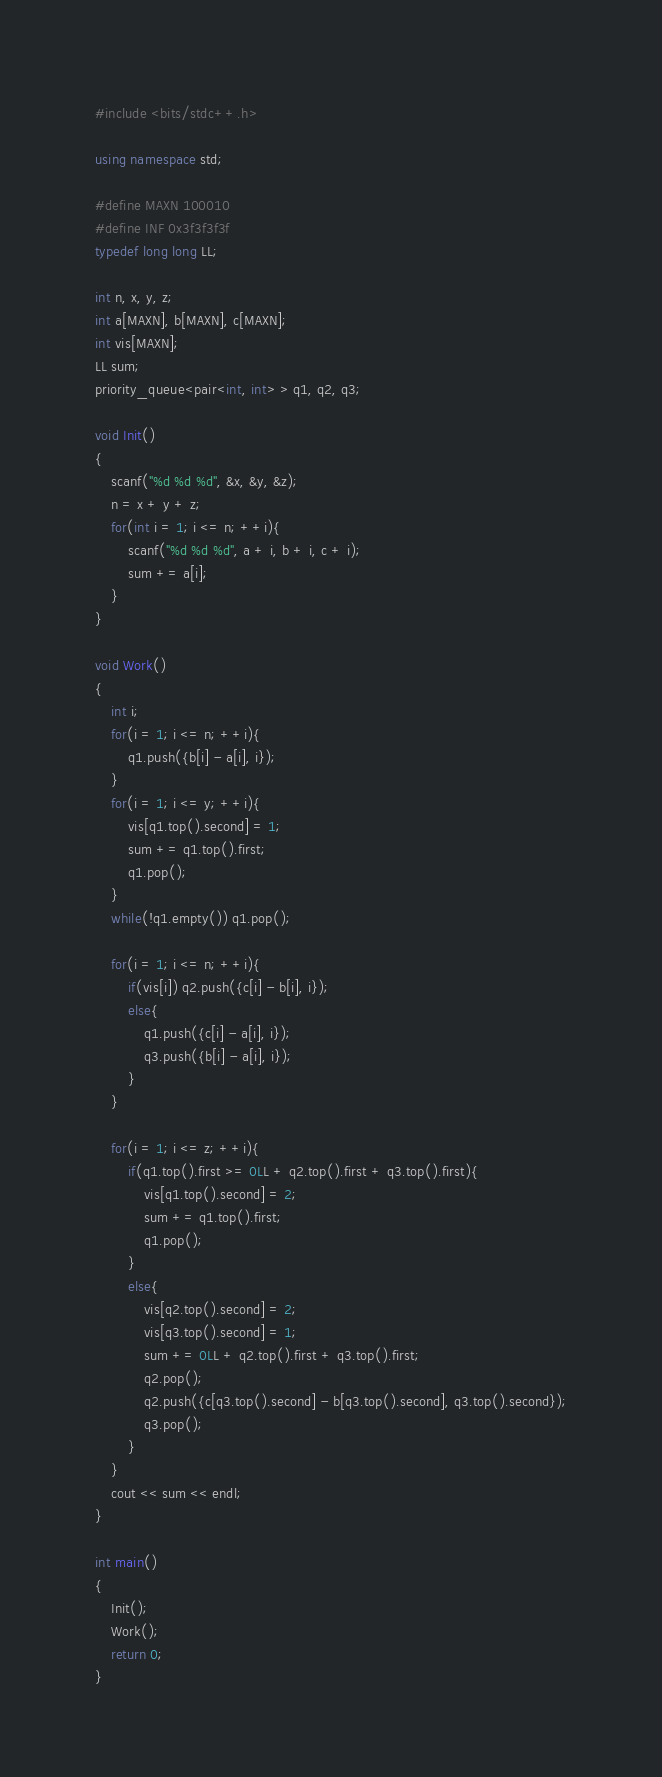Convert code to text. <code><loc_0><loc_0><loc_500><loc_500><_C++_>#include <bits/stdc++.h>

using namespace std;

#define MAXN 100010
#define INF 0x3f3f3f3f
typedef long long LL;

int n, x, y, z;
int a[MAXN], b[MAXN], c[MAXN];
int vis[MAXN];
LL sum;
priority_queue<pair<int, int> > q1, q2, q3;

void Init()
{
    scanf("%d %d %d", &x, &y, &z);
    n = x + y + z;
    for(int i = 1; i <= n; ++i){
        scanf("%d %d %d", a + i, b + i, c + i);
        sum += a[i];
    }
}

void Work()
{
    int i;
    for(i = 1; i <= n; ++i){
        q1.push({b[i] - a[i], i});
    }
    for(i = 1; i <= y; ++i){
        vis[q1.top().second] = 1;
        sum += q1.top().first;
        q1.pop();
    }
    while(!q1.empty()) q1.pop();

    for(i = 1; i <= n; ++i){
        if(vis[i]) q2.push({c[i] - b[i], i});
        else{
            q1.push({c[i] - a[i], i});
            q3.push({b[i] - a[i], i});
        }
    }

    for(i = 1; i <= z; ++i){
        if(q1.top().first >= 0LL + q2.top().first + q3.top().first){
            vis[q1.top().second] = 2;
            sum += q1.top().first;
            q1.pop();
        }
        else{
            vis[q2.top().second] = 2;
            vis[q3.top().second] = 1;
            sum += 0LL + q2.top().first + q3.top().first;
            q2.pop();
            q2.push({c[q3.top().second] - b[q3.top().second], q3.top().second});
            q3.pop();
        }
    }
    cout << sum << endl;
}

int main()
{
    Init();
    Work();
    return 0;
}
</code> 